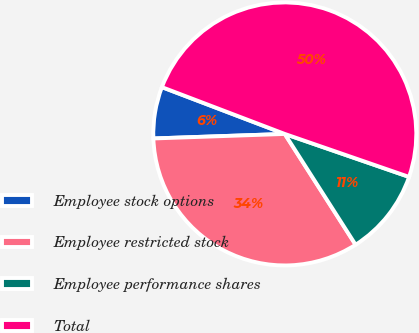Convert chart to OTSL. <chart><loc_0><loc_0><loc_500><loc_500><pie_chart><fcel>Employee stock options<fcel>Employee restricted stock<fcel>Employee performance shares<fcel>Total<nl><fcel>6.34%<fcel>33.5%<fcel>10.65%<fcel>49.5%<nl></chart> 